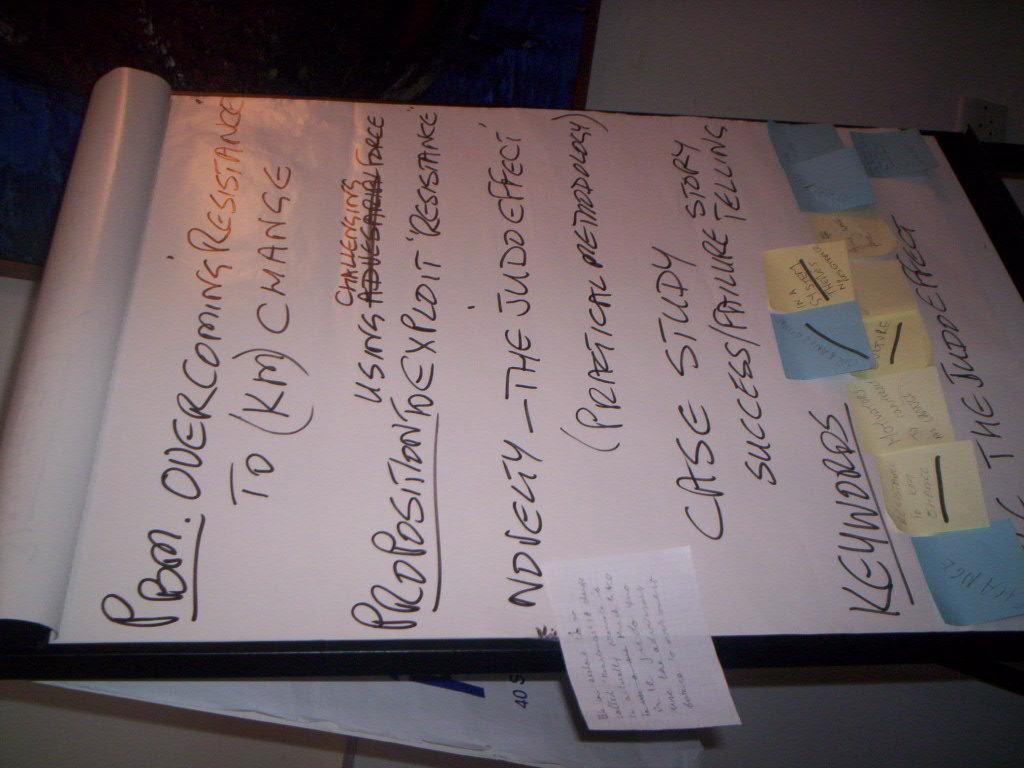What is the topic of these notes?
Offer a very short reply. Overcoming resistance. What is written in the last row of the notes?
Offer a terse response. The judd effect. 